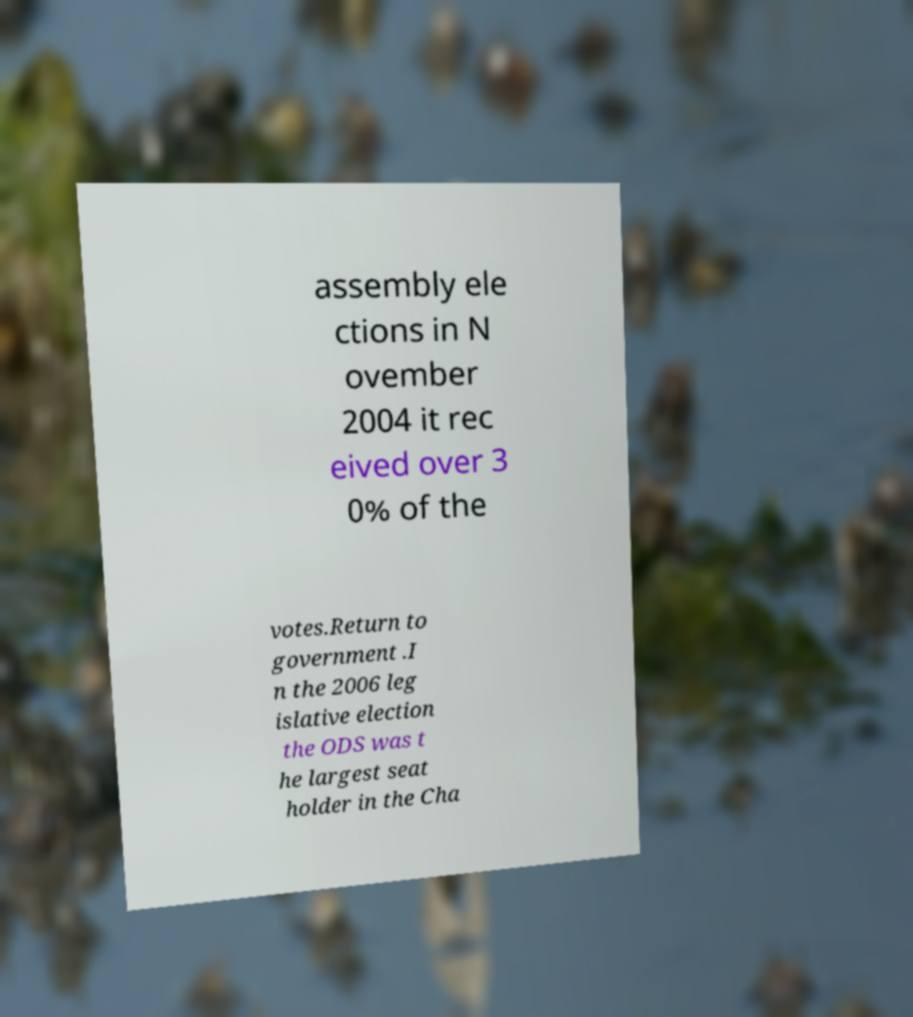Can you accurately transcribe the text from the provided image for me? assembly ele ctions in N ovember 2004 it rec eived over 3 0% of the votes.Return to government .I n the 2006 leg islative election the ODS was t he largest seat holder in the Cha 